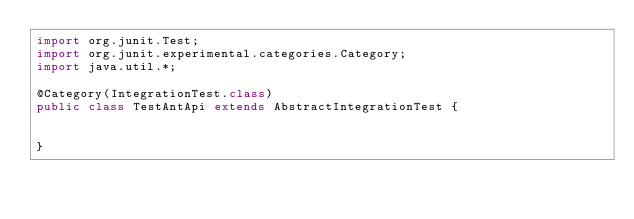<code> <loc_0><loc_0><loc_500><loc_500><_Java_>import org.junit.Test;
import org.junit.experimental.categories.Category;
import java.util.*;

@Category(IntegrationTest.class)
public class TestAntApi extends AbstractIntegrationTest {
  
	
}
</code> 